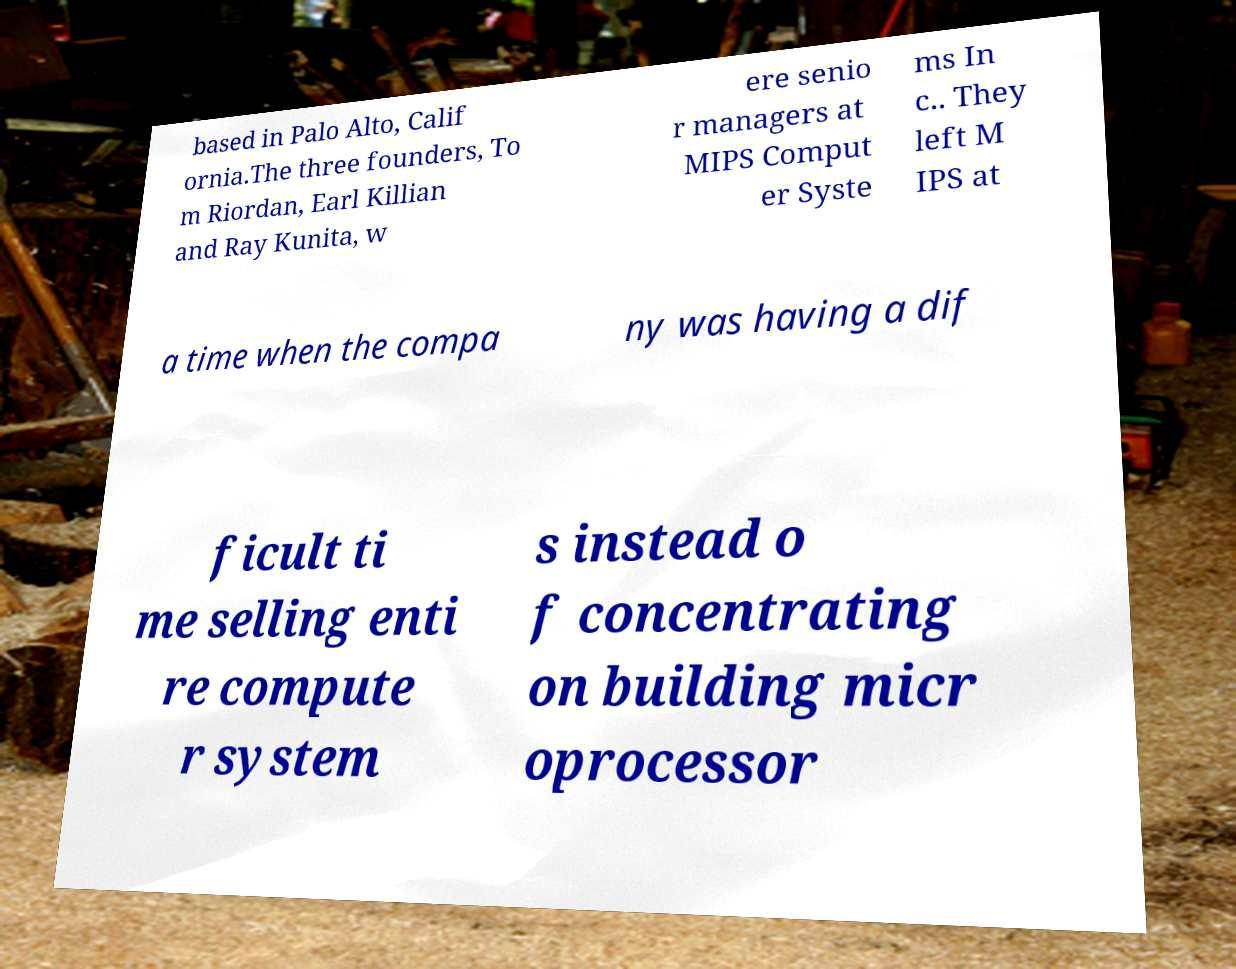Can you accurately transcribe the text from the provided image for me? based in Palo Alto, Calif ornia.The three founders, To m Riordan, Earl Killian and Ray Kunita, w ere senio r managers at MIPS Comput er Syste ms In c.. They left M IPS at a time when the compa ny was having a dif ficult ti me selling enti re compute r system s instead o f concentrating on building micr oprocessor 